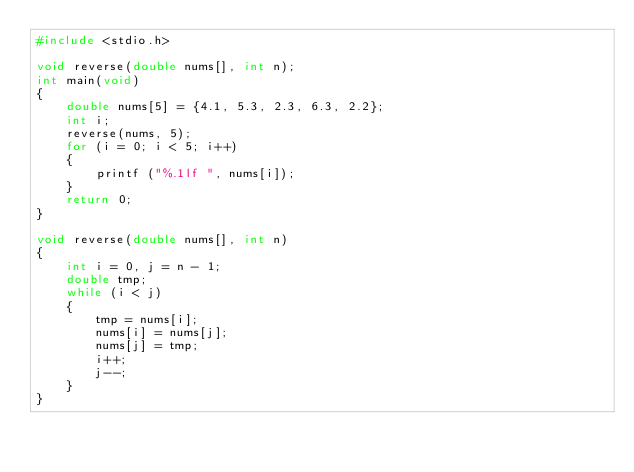<code> <loc_0><loc_0><loc_500><loc_500><_C_>#include <stdio.h>

void reverse(double nums[], int n);
int main(void)
{
    double nums[5] = {4.1, 5.3, 2.3, 6.3, 2.2};
    int i;
    reverse(nums, 5);
    for (i = 0; i < 5; i++)
    {
        printf ("%.1lf ", nums[i]);
    }
    return 0;
}

void reverse(double nums[], int n)
{
    int i = 0, j = n - 1;
    double tmp;
    while (i < j)
    {
        tmp = nums[i];
        nums[i] = nums[j];
        nums[j] = tmp;
        i++;
        j--;
    }
}</code> 